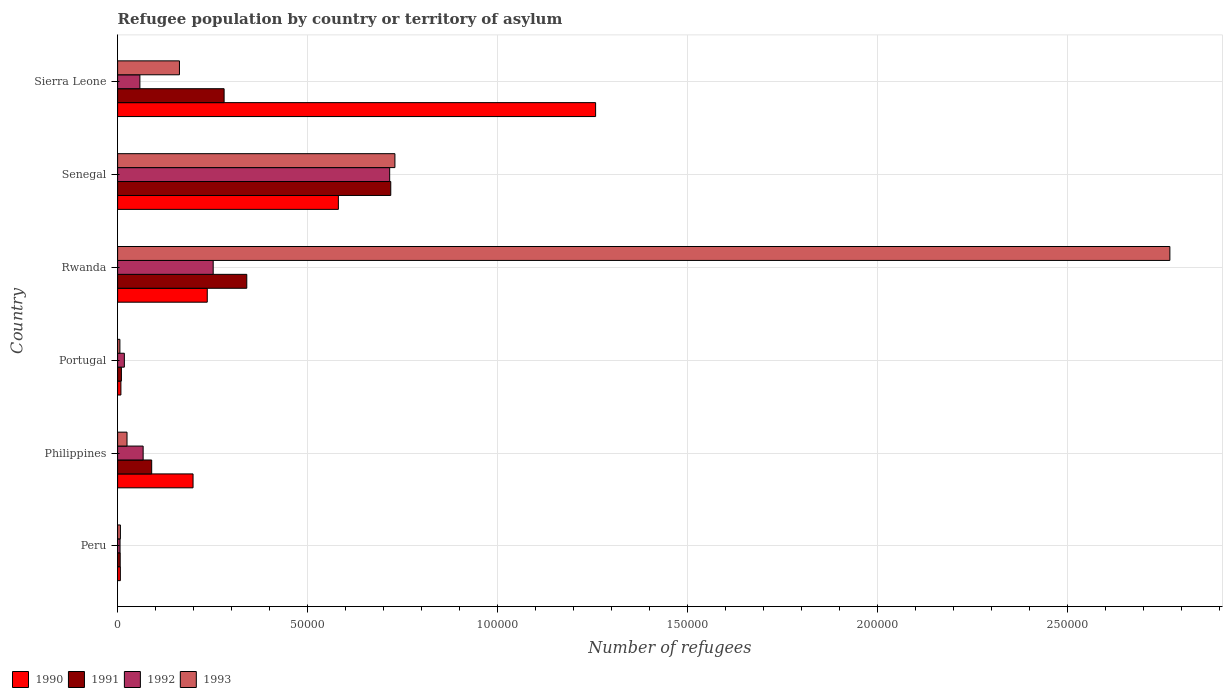Are the number of bars per tick equal to the number of legend labels?
Offer a terse response. Yes. Are the number of bars on each tick of the Y-axis equal?
Your answer should be compact. Yes. How many bars are there on the 4th tick from the bottom?
Ensure brevity in your answer.  4. What is the label of the 1st group of bars from the top?
Make the answer very short. Sierra Leone. In how many cases, is the number of bars for a given country not equal to the number of legend labels?
Your response must be concise. 0. What is the number of refugees in 1991 in Rwanda?
Your response must be concise. 3.40e+04. Across all countries, what is the maximum number of refugees in 1990?
Your answer should be compact. 1.26e+05. Across all countries, what is the minimum number of refugees in 1990?
Offer a terse response. 724. In which country was the number of refugees in 1993 maximum?
Provide a short and direct response. Rwanda. In which country was the number of refugees in 1991 minimum?
Provide a succinct answer. Peru. What is the total number of refugees in 1990 in the graph?
Give a very brief answer. 2.29e+05. What is the difference between the number of refugees in 1991 in Philippines and that in Sierra Leone?
Your answer should be very brief. -1.91e+04. What is the difference between the number of refugees in 1992 in Portugal and the number of refugees in 1990 in Senegal?
Ensure brevity in your answer.  -5.63e+04. What is the average number of refugees in 1993 per country?
Your response must be concise. 6.17e+04. What is the difference between the number of refugees in 1990 and number of refugees in 1993 in Sierra Leone?
Keep it short and to the point. 1.10e+05. What is the ratio of the number of refugees in 1993 in Philippines to that in Senegal?
Ensure brevity in your answer.  0.03. What is the difference between the highest and the second highest number of refugees in 1993?
Keep it short and to the point. 2.04e+05. What is the difference between the highest and the lowest number of refugees in 1992?
Provide a succinct answer. 7.10e+04. In how many countries, is the number of refugees in 1991 greater than the average number of refugees in 1991 taken over all countries?
Ensure brevity in your answer.  3. Is the sum of the number of refugees in 1993 in Portugal and Rwanda greater than the maximum number of refugees in 1991 across all countries?
Ensure brevity in your answer.  Yes. Is it the case that in every country, the sum of the number of refugees in 1992 and number of refugees in 1991 is greater than the sum of number of refugees in 1990 and number of refugees in 1993?
Provide a succinct answer. No. What does the 4th bar from the top in Peru represents?
Your answer should be very brief. 1990. How many bars are there?
Your response must be concise. 24. Are the values on the major ticks of X-axis written in scientific E-notation?
Your answer should be compact. No. Does the graph contain any zero values?
Make the answer very short. No. Where does the legend appear in the graph?
Make the answer very short. Bottom left. How many legend labels are there?
Provide a succinct answer. 4. How are the legend labels stacked?
Your answer should be very brief. Horizontal. What is the title of the graph?
Provide a short and direct response. Refugee population by country or territory of asylum. What is the label or title of the X-axis?
Provide a short and direct response. Number of refugees. What is the Number of refugees of 1990 in Peru?
Your answer should be very brief. 724. What is the Number of refugees in 1991 in Peru?
Give a very brief answer. 683. What is the Number of refugees in 1992 in Peru?
Give a very brief answer. 640. What is the Number of refugees of 1993 in Peru?
Offer a terse response. 738. What is the Number of refugees of 1990 in Philippines?
Make the answer very short. 1.99e+04. What is the Number of refugees of 1991 in Philippines?
Your response must be concise. 8972. What is the Number of refugees of 1992 in Philippines?
Provide a succinct answer. 6722. What is the Number of refugees of 1993 in Philippines?
Offer a terse response. 2477. What is the Number of refugees of 1990 in Portugal?
Ensure brevity in your answer.  867. What is the Number of refugees in 1991 in Portugal?
Ensure brevity in your answer.  998. What is the Number of refugees of 1992 in Portugal?
Keep it short and to the point. 1778. What is the Number of refugees in 1993 in Portugal?
Ensure brevity in your answer.  600. What is the Number of refugees of 1990 in Rwanda?
Keep it short and to the point. 2.36e+04. What is the Number of refugees of 1991 in Rwanda?
Provide a short and direct response. 3.40e+04. What is the Number of refugees of 1992 in Rwanda?
Your answer should be very brief. 2.52e+04. What is the Number of refugees in 1993 in Rwanda?
Your answer should be compact. 2.77e+05. What is the Number of refugees in 1990 in Senegal?
Make the answer very short. 5.81e+04. What is the Number of refugees in 1991 in Senegal?
Your answer should be compact. 7.19e+04. What is the Number of refugees of 1992 in Senegal?
Offer a very short reply. 7.16e+04. What is the Number of refugees in 1993 in Senegal?
Keep it short and to the point. 7.30e+04. What is the Number of refugees of 1990 in Sierra Leone?
Offer a very short reply. 1.26e+05. What is the Number of refugees in 1991 in Sierra Leone?
Provide a succinct answer. 2.80e+04. What is the Number of refugees of 1992 in Sierra Leone?
Your answer should be compact. 5866. What is the Number of refugees in 1993 in Sierra Leone?
Provide a succinct answer. 1.63e+04. Across all countries, what is the maximum Number of refugees in 1990?
Ensure brevity in your answer.  1.26e+05. Across all countries, what is the maximum Number of refugees in 1991?
Offer a very short reply. 7.19e+04. Across all countries, what is the maximum Number of refugees in 1992?
Give a very brief answer. 7.16e+04. Across all countries, what is the maximum Number of refugees of 1993?
Ensure brevity in your answer.  2.77e+05. Across all countries, what is the minimum Number of refugees of 1990?
Provide a succinct answer. 724. Across all countries, what is the minimum Number of refugees of 1991?
Offer a very short reply. 683. Across all countries, what is the minimum Number of refugees in 1992?
Offer a very short reply. 640. Across all countries, what is the minimum Number of refugees of 1993?
Ensure brevity in your answer.  600. What is the total Number of refugees in 1990 in the graph?
Keep it short and to the point. 2.29e+05. What is the total Number of refugees of 1991 in the graph?
Keep it short and to the point. 1.45e+05. What is the total Number of refugees of 1992 in the graph?
Offer a terse response. 1.12e+05. What is the total Number of refugees in 1993 in the graph?
Your response must be concise. 3.70e+05. What is the difference between the Number of refugees in 1990 in Peru and that in Philippines?
Your answer should be very brief. -1.91e+04. What is the difference between the Number of refugees in 1991 in Peru and that in Philippines?
Give a very brief answer. -8289. What is the difference between the Number of refugees of 1992 in Peru and that in Philippines?
Provide a succinct answer. -6082. What is the difference between the Number of refugees in 1993 in Peru and that in Philippines?
Offer a terse response. -1739. What is the difference between the Number of refugees in 1990 in Peru and that in Portugal?
Your answer should be compact. -143. What is the difference between the Number of refugees of 1991 in Peru and that in Portugal?
Provide a short and direct response. -315. What is the difference between the Number of refugees in 1992 in Peru and that in Portugal?
Ensure brevity in your answer.  -1138. What is the difference between the Number of refugees of 1993 in Peru and that in Portugal?
Your answer should be very brief. 138. What is the difference between the Number of refugees in 1990 in Peru and that in Rwanda?
Ensure brevity in your answer.  -2.29e+04. What is the difference between the Number of refugees of 1991 in Peru and that in Rwanda?
Give a very brief answer. -3.33e+04. What is the difference between the Number of refugees in 1992 in Peru and that in Rwanda?
Offer a terse response. -2.45e+04. What is the difference between the Number of refugees in 1993 in Peru and that in Rwanda?
Keep it short and to the point. -2.76e+05. What is the difference between the Number of refugees in 1990 in Peru and that in Senegal?
Give a very brief answer. -5.74e+04. What is the difference between the Number of refugees in 1991 in Peru and that in Senegal?
Provide a succinct answer. -7.12e+04. What is the difference between the Number of refugees in 1992 in Peru and that in Senegal?
Your answer should be compact. -7.10e+04. What is the difference between the Number of refugees in 1993 in Peru and that in Senegal?
Give a very brief answer. -7.23e+04. What is the difference between the Number of refugees in 1990 in Peru and that in Sierra Leone?
Give a very brief answer. -1.25e+05. What is the difference between the Number of refugees in 1991 in Peru and that in Sierra Leone?
Give a very brief answer. -2.74e+04. What is the difference between the Number of refugees in 1992 in Peru and that in Sierra Leone?
Provide a short and direct response. -5226. What is the difference between the Number of refugees in 1993 in Peru and that in Sierra Leone?
Give a very brief answer. -1.55e+04. What is the difference between the Number of refugees in 1990 in Philippines and that in Portugal?
Keep it short and to the point. 1.90e+04. What is the difference between the Number of refugees of 1991 in Philippines and that in Portugal?
Provide a short and direct response. 7974. What is the difference between the Number of refugees of 1992 in Philippines and that in Portugal?
Your answer should be compact. 4944. What is the difference between the Number of refugees in 1993 in Philippines and that in Portugal?
Your answer should be compact. 1877. What is the difference between the Number of refugees of 1990 in Philippines and that in Rwanda?
Provide a succinct answer. -3741. What is the difference between the Number of refugees of 1991 in Philippines and that in Rwanda?
Give a very brief answer. -2.50e+04. What is the difference between the Number of refugees in 1992 in Philippines and that in Rwanda?
Provide a succinct answer. -1.84e+04. What is the difference between the Number of refugees of 1993 in Philippines and that in Rwanda?
Give a very brief answer. -2.75e+05. What is the difference between the Number of refugees in 1990 in Philippines and that in Senegal?
Your response must be concise. -3.83e+04. What is the difference between the Number of refugees in 1991 in Philippines and that in Senegal?
Your response must be concise. -6.29e+04. What is the difference between the Number of refugees in 1992 in Philippines and that in Senegal?
Make the answer very short. -6.49e+04. What is the difference between the Number of refugees of 1993 in Philippines and that in Senegal?
Offer a very short reply. -7.05e+04. What is the difference between the Number of refugees in 1990 in Philippines and that in Sierra Leone?
Make the answer very short. -1.06e+05. What is the difference between the Number of refugees of 1991 in Philippines and that in Sierra Leone?
Offer a very short reply. -1.91e+04. What is the difference between the Number of refugees of 1992 in Philippines and that in Sierra Leone?
Keep it short and to the point. 856. What is the difference between the Number of refugees in 1993 in Philippines and that in Sierra Leone?
Make the answer very short. -1.38e+04. What is the difference between the Number of refugees of 1990 in Portugal and that in Rwanda?
Provide a short and direct response. -2.27e+04. What is the difference between the Number of refugees of 1991 in Portugal and that in Rwanda?
Make the answer very short. -3.30e+04. What is the difference between the Number of refugees in 1992 in Portugal and that in Rwanda?
Give a very brief answer. -2.34e+04. What is the difference between the Number of refugees in 1993 in Portugal and that in Rwanda?
Give a very brief answer. -2.76e+05. What is the difference between the Number of refugees of 1990 in Portugal and that in Senegal?
Make the answer very short. -5.72e+04. What is the difference between the Number of refugees in 1991 in Portugal and that in Senegal?
Provide a succinct answer. -7.09e+04. What is the difference between the Number of refugees in 1992 in Portugal and that in Senegal?
Make the answer very short. -6.98e+04. What is the difference between the Number of refugees in 1993 in Portugal and that in Senegal?
Your response must be concise. -7.24e+04. What is the difference between the Number of refugees of 1990 in Portugal and that in Sierra Leone?
Provide a short and direct response. -1.25e+05. What is the difference between the Number of refugees of 1991 in Portugal and that in Sierra Leone?
Provide a short and direct response. -2.70e+04. What is the difference between the Number of refugees of 1992 in Portugal and that in Sierra Leone?
Your answer should be compact. -4088. What is the difference between the Number of refugees of 1993 in Portugal and that in Sierra Leone?
Make the answer very short. -1.57e+04. What is the difference between the Number of refugees of 1990 in Rwanda and that in Senegal?
Your answer should be very brief. -3.45e+04. What is the difference between the Number of refugees of 1991 in Rwanda and that in Senegal?
Provide a succinct answer. -3.79e+04. What is the difference between the Number of refugees of 1992 in Rwanda and that in Senegal?
Offer a terse response. -4.65e+04. What is the difference between the Number of refugees of 1993 in Rwanda and that in Senegal?
Offer a very short reply. 2.04e+05. What is the difference between the Number of refugees of 1990 in Rwanda and that in Sierra Leone?
Your answer should be compact. -1.02e+05. What is the difference between the Number of refugees in 1991 in Rwanda and that in Sierra Leone?
Your response must be concise. 5968. What is the difference between the Number of refugees of 1992 in Rwanda and that in Sierra Leone?
Provide a succinct answer. 1.93e+04. What is the difference between the Number of refugees in 1993 in Rwanda and that in Sierra Leone?
Your response must be concise. 2.61e+05. What is the difference between the Number of refugees in 1990 in Senegal and that in Sierra Leone?
Your answer should be compact. -6.77e+04. What is the difference between the Number of refugees in 1991 in Senegal and that in Sierra Leone?
Your answer should be very brief. 4.39e+04. What is the difference between the Number of refugees in 1992 in Senegal and that in Sierra Leone?
Give a very brief answer. 6.58e+04. What is the difference between the Number of refugees of 1993 in Senegal and that in Sierra Leone?
Give a very brief answer. 5.67e+04. What is the difference between the Number of refugees of 1990 in Peru and the Number of refugees of 1991 in Philippines?
Offer a very short reply. -8248. What is the difference between the Number of refugees in 1990 in Peru and the Number of refugees in 1992 in Philippines?
Your response must be concise. -5998. What is the difference between the Number of refugees of 1990 in Peru and the Number of refugees of 1993 in Philippines?
Provide a succinct answer. -1753. What is the difference between the Number of refugees of 1991 in Peru and the Number of refugees of 1992 in Philippines?
Provide a short and direct response. -6039. What is the difference between the Number of refugees of 1991 in Peru and the Number of refugees of 1993 in Philippines?
Make the answer very short. -1794. What is the difference between the Number of refugees of 1992 in Peru and the Number of refugees of 1993 in Philippines?
Your response must be concise. -1837. What is the difference between the Number of refugees in 1990 in Peru and the Number of refugees in 1991 in Portugal?
Offer a terse response. -274. What is the difference between the Number of refugees in 1990 in Peru and the Number of refugees in 1992 in Portugal?
Provide a succinct answer. -1054. What is the difference between the Number of refugees of 1990 in Peru and the Number of refugees of 1993 in Portugal?
Your answer should be compact. 124. What is the difference between the Number of refugees of 1991 in Peru and the Number of refugees of 1992 in Portugal?
Make the answer very short. -1095. What is the difference between the Number of refugees of 1991 in Peru and the Number of refugees of 1993 in Portugal?
Your answer should be compact. 83. What is the difference between the Number of refugees in 1992 in Peru and the Number of refugees in 1993 in Portugal?
Your response must be concise. 40. What is the difference between the Number of refugees of 1990 in Peru and the Number of refugees of 1991 in Rwanda?
Provide a succinct answer. -3.33e+04. What is the difference between the Number of refugees of 1990 in Peru and the Number of refugees of 1992 in Rwanda?
Give a very brief answer. -2.44e+04. What is the difference between the Number of refugees of 1990 in Peru and the Number of refugees of 1993 in Rwanda?
Your answer should be compact. -2.76e+05. What is the difference between the Number of refugees in 1991 in Peru and the Number of refugees in 1992 in Rwanda?
Your answer should be compact. -2.45e+04. What is the difference between the Number of refugees in 1991 in Peru and the Number of refugees in 1993 in Rwanda?
Your response must be concise. -2.76e+05. What is the difference between the Number of refugees of 1992 in Peru and the Number of refugees of 1993 in Rwanda?
Keep it short and to the point. -2.76e+05. What is the difference between the Number of refugees in 1990 in Peru and the Number of refugees in 1991 in Senegal?
Ensure brevity in your answer.  -7.12e+04. What is the difference between the Number of refugees of 1990 in Peru and the Number of refugees of 1992 in Senegal?
Keep it short and to the point. -7.09e+04. What is the difference between the Number of refugees in 1990 in Peru and the Number of refugees in 1993 in Senegal?
Provide a short and direct response. -7.23e+04. What is the difference between the Number of refugees in 1991 in Peru and the Number of refugees in 1992 in Senegal?
Your response must be concise. -7.09e+04. What is the difference between the Number of refugees of 1991 in Peru and the Number of refugees of 1993 in Senegal?
Make the answer very short. -7.23e+04. What is the difference between the Number of refugees in 1992 in Peru and the Number of refugees in 1993 in Senegal?
Ensure brevity in your answer.  -7.24e+04. What is the difference between the Number of refugees of 1990 in Peru and the Number of refugees of 1991 in Sierra Leone?
Offer a very short reply. -2.73e+04. What is the difference between the Number of refugees of 1990 in Peru and the Number of refugees of 1992 in Sierra Leone?
Make the answer very short. -5142. What is the difference between the Number of refugees of 1990 in Peru and the Number of refugees of 1993 in Sierra Leone?
Ensure brevity in your answer.  -1.56e+04. What is the difference between the Number of refugees of 1991 in Peru and the Number of refugees of 1992 in Sierra Leone?
Keep it short and to the point. -5183. What is the difference between the Number of refugees of 1991 in Peru and the Number of refugees of 1993 in Sierra Leone?
Your answer should be compact. -1.56e+04. What is the difference between the Number of refugees of 1992 in Peru and the Number of refugees of 1993 in Sierra Leone?
Your answer should be very brief. -1.56e+04. What is the difference between the Number of refugees of 1990 in Philippines and the Number of refugees of 1991 in Portugal?
Give a very brief answer. 1.89e+04. What is the difference between the Number of refugees in 1990 in Philippines and the Number of refugees in 1992 in Portugal?
Give a very brief answer. 1.81e+04. What is the difference between the Number of refugees of 1990 in Philippines and the Number of refugees of 1993 in Portugal?
Your answer should be compact. 1.93e+04. What is the difference between the Number of refugees of 1991 in Philippines and the Number of refugees of 1992 in Portugal?
Your answer should be very brief. 7194. What is the difference between the Number of refugees in 1991 in Philippines and the Number of refugees in 1993 in Portugal?
Ensure brevity in your answer.  8372. What is the difference between the Number of refugees in 1992 in Philippines and the Number of refugees in 1993 in Portugal?
Offer a very short reply. 6122. What is the difference between the Number of refugees of 1990 in Philippines and the Number of refugees of 1991 in Rwanda?
Ensure brevity in your answer.  -1.41e+04. What is the difference between the Number of refugees in 1990 in Philippines and the Number of refugees in 1992 in Rwanda?
Your answer should be very brief. -5302. What is the difference between the Number of refugees in 1990 in Philippines and the Number of refugees in 1993 in Rwanda?
Offer a very short reply. -2.57e+05. What is the difference between the Number of refugees of 1991 in Philippines and the Number of refugees of 1992 in Rwanda?
Offer a terse response. -1.62e+04. What is the difference between the Number of refugees in 1991 in Philippines and the Number of refugees in 1993 in Rwanda?
Offer a very short reply. -2.68e+05. What is the difference between the Number of refugees in 1992 in Philippines and the Number of refugees in 1993 in Rwanda?
Your answer should be compact. -2.70e+05. What is the difference between the Number of refugees in 1990 in Philippines and the Number of refugees in 1991 in Senegal?
Keep it short and to the point. -5.20e+04. What is the difference between the Number of refugees in 1990 in Philippines and the Number of refugees in 1992 in Senegal?
Keep it short and to the point. -5.18e+04. What is the difference between the Number of refugees of 1990 in Philippines and the Number of refugees of 1993 in Senegal?
Provide a short and direct response. -5.31e+04. What is the difference between the Number of refugees in 1991 in Philippines and the Number of refugees in 1992 in Senegal?
Keep it short and to the point. -6.26e+04. What is the difference between the Number of refugees in 1991 in Philippines and the Number of refugees in 1993 in Senegal?
Offer a very short reply. -6.40e+04. What is the difference between the Number of refugees in 1992 in Philippines and the Number of refugees in 1993 in Senegal?
Provide a succinct answer. -6.63e+04. What is the difference between the Number of refugees of 1990 in Philippines and the Number of refugees of 1991 in Sierra Leone?
Your answer should be compact. -8176. What is the difference between the Number of refugees of 1990 in Philippines and the Number of refugees of 1992 in Sierra Leone?
Give a very brief answer. 1.40e+04. What is the difference between the Number of refugees in 1990 in Philippines and the Number of refugees in 1993 in Sierra Leone?
Your answer should be compact. 3581. What is the difference between the Number of refugees in 1991 in Philippines and the Number of refugees in 1992 in Sierra Leone?
Your answer should be compact. 3106. What is the difference between the Number of refugees of 1991 in Philippines and the Number of refugees of 1993 in Sierra Leone?
Your response must be concise. -7307. What is the difference between the Number of refugees in 1992 in Philippines and the Number of refugees in 1993 in Sierra Leone?
Offer a terse response. -9557. What is the difference between the Number of refugees in 1990 in Portugal and the Number of refugees in 1991 in Rwanda?
Make the answer very short. -3.31e+04. What is the difference between the Number of refugees of 1990 in Portugal and the Number of refugees of 1992 in Rwanda?
Make the answer very short. -2.43e+04. What is the difference between the Number of refugees of 1990 in Portugal and the Number of refugees of 1993 in Rwanda?
Ensure brevity in your answer.  -2.76e+05. What is the difference between the Number of refugees in 1991 in Portugal and the Number of refugees in 1992 in Rwanda?
Provide a short and direct response. -2.42e+04. What is the difference between the Number of refugees of 1991 in Portugal and the Number of refugees of 1993 in Rwanda?
Your answer should be compact. -2.76e+05. What is the difference between the Number of refugees in 1992 in Portugal and the Number of refugees in 1993 in Rwanda?
Ensure brevity in your answer.  -2.75e+05. What is the difference between the Number of refugees of 1990 in Portugal and the Number of refugees of 1991 in Senegal?
Your response must be concise. -7.10e+04. What is the difference between the Number of refugees of 1990 in Portugal and the Number of refugees of 1992 in Senegal?
Your response must be concise. -7.08e+04. What is the difference between the Number of refugees of 1990 in Portugal and the Number of refugees of 1993 in Senegal?
Your answer should be compact. -7.21e+04. What is the difference between the Number of refugees of 1991 in Portugal and the Number of refugees of 1992 in Senegal?
Your response must be concise. -7.06e+04. What is the difference between the Number of refugees in 1991 in Portugal and the Number of refugees in 1993 in Senegal?
Offer a terse response. -7.20e+04. What is the difference between the Number of refugees in 1992 in Portugal and the Number of refugees in 1993 in Senegal?
Make the answer very short. -7.12e+04. What is the difference between the Number of refugees in 1990 in Portugal and the Number of refugees in 1991 in Sierra Leone?
Your answer should be compact. -2.72e+04. What is the difference between the Number of refugees of 1990 in Portugal and the Number of refugees of 1992 in Sierra Leone?
Offer a very short reply. -4999. What is the difference between the Number of refugees in 1990 in Portugal and the Number of refugees in 1993 in Sierra Leone?
Make the answer very short. -1.54e+04. What is the difference between the Number of refugees in 1991 in Portugal and the Number of refugees in 1992 in Sierra Leone?
Your response must be concise. -4868. What is the difference between the Number of refugees of 1991 in Portugal and the Number of refugees of 1993 in Sierra Leone?
Provide a short and direct response. -1.53e+04. What is the difference between the Number of refugees of 1992 in Portugal and the Number of refugees of 1993 in Sierra Leone?
Keep it short and to the point. -1.45e+04. What is the difference between the Number of refugees in 1990 in Rwanda and the Number of refugees in 1991 in Senegal?
Your answer should be compact. -4.83e+04. What is the difference between the Number of refugees in 1990 in Rwanda and the Number of refugees in 1992 in Senegal?
Give a very brief answer. -4.80e+04. What is the difference between the Number of refugees of 1990 in Rwanda and the Number of refugees of 1993 in Senegal?
Offer a very short reply. -4.94e+04. What is the difference between the Number of refugees in 1991 in Rwanda and the Number of refugees in 1992 in Senegal?
Offer a very short reply. -3.76e+04. What is the difference between the Number of refugees of 1991 in Rwanda and the Number of refugees of 1993 in Senegal?
Offer a terse response. -3.90e+04. What is the difference between the Number of refugees in 1992 in Rwanda and the Number of refugees in 1993 in Senegal?
Give a very brief answer. -4.78e+04. What is the difference between the Number of refugees in 1990 in Rwanda and the Number of refugees in 1991 in Sierra Leone?
Offer a very short reply. -4435. What is the difference between the Number of refugees in 1990 in Rwanda and the Number of refugees in 1992 in Sierra Leone?
Make the answer very short. 1.77e+04. What is the difference between the Number of refugees in 1990 in Rwanda and the Number of refugees in 1993 in Sierra Leone?
Provide a succinct answer. 7322. What is the difference between the Number of refugees in 1991 in Rwanda and the Number of refugees in 1992 in Sierra Leone?
Offer a very short reply. 2.81e+04. What is the difference between the Number of refugees of 1991 in Rwanda and the Number of refugees of 1993 in Sierra Leone?
Give a very brief answer. 1.77e+04. What is the difference between the Number of refugees of 1992 in Rwanda and the Number of refugees of 1993 in Sierra Leone?
Provide a short and direct response. 8883. What is the difference between the Number of refugees of 1990 in Senegal and the Number of refugees of 1991 in Sierra Leone?
Give a very brief answer. 3.01e+04. What is the difference between the Number of refugees in 1990 in Senegal and the Number of refugees in 1992 in Sierra Leone?
Provide a succinct answer. 5.22e+04. What is the difference between the Number of refugees in 1990 in Senegal and the Number of refugees in 1993 in Sierra Leone?
Ensure brevity in your answer.  4.18e+04. What is the difference between the Number of refugees of 1991 in Senegal and the Number of refugees of 1992 in Sierra Leone?
Give a very brief answer. 6.60e+04. What is the difference between the Number of refugees of 1991 in Senegal and the Number of refugees of 1993 in Sierra Leone?
Your answer should be very brief. 5.56e+04. What is the difference between the Number of refugees in 1992 in Senegal and the Number of refugees in 1993 in Sierra Leone?
Offer a terse response. 5.53e+04. What is the average Number of refugees in 1990 per country?
Your answer should be very brief. 3.82e+04. What is the average Number of refugees in 1991 per country?
Your answer should be compact. 2.41e+04. What is the average Number of refugees in 1992 per country?
Offer a terse response. 1.86e+04. What is the average Number of refugees in 1993 per country?
Your response must be concise. 6.17e+04. What is the difference between the Number of refugees of 1990 and Number of refugees of 1991 in Peru?
Offer a very short reply. 41. What is the difference between the Number of refugees of 1990 and Number of refugees of 1992 in Peru?
Your answer should be compact. 84. What is the difference between the Number of refugees of 1991 and Number of refugees of 1993 in Peru?
Ensure brevity in your answer.  -55. What is the difference between the Number of refugees in 1992 and Number of refugees in 1993 in Peru?
Ensure brevity in your answer.  -98. What is the difference between the Number of refugees of 1990 and Number of refugees of 1991 in Philippines?
Make the answer very short. 1.09e+04. What is the difference between the Number of refugees of 1990 and Number of refugees of 1992 in Philippines?
Provide a short and direct response. 1.31e+04. What is the difference between the Number of refugees of 1990 and Number of refugees of 1993 in Philippines?
Provide a short and direct response. 1.74e+04. What is the difference between the Number of refugees in 1991 and Number of refugees in 1992 in Philippines?
Ensure brevity in your answer.  2250. What is the difference between the Number of refugees in 1991 and Number of refugees in 1993 in Philippines?
Keep it short and to the point. 6495. What is the difference between the Number of refugees in 1992 and Number of refugees in 1993 in Philippines?
Offer a very short reply. 4245. What is the difference between the Number of refugees of 1990 and Number of refugees of 1991 in Portugal?
Provide a short and direct response. -131. What is the difference between the Number of refugees in 1990 and Number of refugees in 1992 in Portugal?
Make the answer very short. -911. What is the difference between the Number of refugees in 1990 and Number of refugees in 1993 in Portugal?
Your response must be concise. 267. What is the difference between the Number of refugees in 1991 and Number of refugees in 1992 in Portugal?
Provide a short and direct response. -780. What is the difference between the Number of refugees of 1991 and Number of refugees of 1993 in Portugal?
Provide a succinct answer. 398. What is the difference between the Number of refugees in 1992 and Number of refugees in 1993 in Portugal?
Your answer should be very brief. 1178. What is the difference between the Number of refugees in 1990 and Number of refugees in 1991 in Rwanda?
Provide a short and direct response. -1.04e+04. What is the difference between the Number of refugees of 1990 and Number of refugees of 1992 in Rwanda?
Provide a succinct answer. -1561. What is the difference between the Number of refugees of 1990 and Number of refugees of 1993 in Rwanda?
Offer a terse response. -2.53e+05. What is the difference between the Number of refugees in 1991 and Number of refugees in 1992 in Rwanda?
Your answer should be compact. 8842. What is the difference between the Number of refugees of 1991 and Number of refugees of 1993 in Rwanda?
Make the answer very short. -2.43e+05. What is the difference between the Number of refugees in 1992 and Number of refugees in 1993 in Rwanda?
Make the answer very short. -2.52e+05. What is the difference between the Number of refugees in 1990 and Number of refugees in 1991 in Senegal?
Your response must be concise. -1.38e+04. What is the difference between the Number of refugees of 1990 and Number of refugees of 1992 in Senegal?
Your answer should be very brief. -1.35e+04. What is the difference between the Number of refugees in 1990 and Number of refugees in 1993 in Senegal?
Offer a terse response. -1.49e+04. What is the difference between the Number of refugees in 1991 and Number of refugees in 1992 in Senegal?
Offer a very short reply. 288. What is the difference between the Number of refugees of 1991 and Number of refugees of 1993 in Senegal?
Give a very brief answer. -1094. What is the difference between the Number of refugees in 1992 and Number of refugees in 1993 in Senegal?
Provide a succinct answer. -1382. What is the difference between the Number of refugees of 1990 and Number of refugees of 1991 in Sierra Leone?
Provide a short and direct response. 9.78e+04. What is the difference between the Number of refugees in 1990 and Number of refugees in 1992 in Sierra Leone?
Give a very brief answer. 1.20e+05. What is the difference between the Number of refugees in 1990 and Number of refugees in 1993 in Sierra Leone?
Your response must be concise. 1.10e+05. What is the difference between the Number of refugees in 1991 and Number of refugees in 1992 in Sierra Leone?
Your answer should be compact. 2.22e+04. What is the difference between the Number of refugees of 1991 and Number of refugees of 1993 in Sierra Leone?
Your answer should be compact. 1.18e+04. What is the difference between the Number of refugees in 1992 and Number of refugees in 1993 in Sierra Leone?
Make the answer very short. -1.04e+04. What is the ratio of the Number of refugees of 1990 in Peru to that in Philippines?
Ensure brevity in your answer.  0.04. What is the ratio of the Number of refugees of 1991 in Peru to that in Philippines?
Offer a terse response. 0.08. What is the ratio of the Number of refugees in 1992 in Peru to that in Philippines?
Provide a succinct answer. 0.1. What is the ratio of the Number of refugees in 1993 in Peru to that in Philippines?
Your answer should be very brief. 0.3. What is the ratio of the Number of refugees of 1990 in Peru to that in Portugal?
Make the answer very short. 0.84. What is the ratio of the Number of refugees of 1991 in Peru to that in Portugal?
Give a very brief answer. 0.68. What is the ratio of the Number of refugees of 1992 in Peru to that in Portugal?
Provide a succinct answer. 0.36. What is the ratio of the Number of refugees in 1993 in Peru to that in Portugal?
Your response must be concise. 1.23. What is the ratio of the Number of refugees in 1990 in Peru to that in Rwanda?
Your response must be concise. 0.03. What is the ratio of the Number of refugees of 1991 in Peru to that in Rwanda?
Your answer should be very brief. 0.02. What is the ratio of the Number of refugees in 1992 in Peru to that in Rwanda?
Provide a short and direct response. 0.03. What is the ratio of the Number of refugees of 1993 in Peru to that in Rwanda?
Offer a terse response. 0. What is the ratio of the Number of refugees of 1990 in Peru to that in Senegal?
Offer a terse response. 0.01. What is the ratio of the Number of refugees in 1991 in Peru to that in Senegal?
Make the answer very short. 0.01. What is the ratio of the Number of refugees of 1992 in Peru to that in Senegal?
Provide a short and direct response. 0.01. What is the ratio of the Number of refugees in 1993 in Peru to that in Senegal?
Keep it short and to the point. 0.01. What is the ratio of the Number of refugees in 1990 in Peru to that in Sierra Leone?
Offer a terse response. 0.01. What is the ratio of the Number of refugees of 1991 in Peru to that in Sierra Leone?
Your answer should be compact. 0.02. What is the ratio of the Number of refugees of 1992 in Peru to that in Sierra Leone?
Provide a succinct answer. 0.11. What is the ratio of the Number of refugees in 1993 in Peru to that in Sierra Leone?
Provide a succinct answer. 0.05. What is the ratio of the Number of refugees in 1990 in Philippines to that in Portugal?
Provide a short and direct response. 22.91. What is the ratio of the Number of refugees in 1991 in Philippines to that in Portugal?
Offer a very short reply. 8.99. What is the ratio of the Number of refugees in 1992 in Philippines to that in Portugal?
Keep it short and to the point. 3.78. What is the ratio of the Number of refugees in 1993 in Philippines to that in Portugal?
Your answer should be compact. 4.13. What is the ratio of the Number of refugees in 1990 in Philippines to that in Rwanda?
Make the answer very short. 0.84. What is the ratio of the Number of refugees of 1991 in Philippines to that in Rwanda?
Make the answer very short. 0.26. What is the ratio of the Number of refugees of 1992 in Philippines to that in Rwanda?
Provide a short and direct response. 0.27. What is the ratio of the Number of refugees in 1993 in Philippines to that in Rwanda?
Provide a short and direct response. 0.01. What is the ratio of the Number of refugees of 1990 in Philippines to that in Senegal?
Give a very brief answer. 0.34. What is the ratio of the Number of refugees of 1991 in Philippines to that in Senegal?
Keep it short and to the point. 0.12. What is the ratio of the Number of refugees of 1992 in Philippines to that in Senegal?
Make the answer very short. 0.09. What is the ratio of the Number of refugees in 1993 in Philippines to that in Senegal?
Provide a succinct answer. 0.03. What is the ratio of the Number of refugees of 1990 in Philippines to that in Sierra Leone?
Your response must be concise. 0.16. What is the ratio of the Number of refugees of 1991 in Philippines to that in Sierra Leone?
Provide a succinct answer. 0.32. What is the ratio of the Number of refugees of 1992 in Philippines to that in Sierra Leone?
Offer a terse response. 1.15. What is the ratio of the Number of refugees in 1993 in Philippines to that in Sierra Leone?
Your response must be concise. 0.15. What is the ratio of the Number of refugees of 1990 in Portugal to that in Rwanda?
Provide a succinct answer. 0.04. What is the ratio of the Number of refugees in 1991 in Portugal to that in Rwanda?
Your response must be concise. 0.03. What is the ratio of the Number of refugees of 1992 in Portugal to that in Rwanda?
Your response must be concise. 0.07. What is the ratio of the Number of refugees of 1993 in Portugal to that in Rwanda?
Offer a terse response. 0. What is the ratio of the Number of refugees of 1990 in Portugal to that in Senegal?
Offer a very short reply. 0.01. What is the ratio of the Number of refugees in 1991 in Portugal to that in Senegal?
Give a very brief answer. 0.01. What is the ratio of the Number of refugees in 1992 in Portugal to that in Senegal?
Ensure brevity in your answer.  0.02. What is the ratio of the Number of refugees in 1993 in Portugal to that in Senegal?
Your answer should be very brief. 0.01. What is the ratio of the Number of refugees in 1990 in Portugal to that in Sierra Leone?
Your answer should be compact. 0.01. What is the ratio of the Number of refugees of 1991 in Portugal to that in Sierra Leone?
Offer a terse response. 0.04. What is the ratio of the Number of refugees of 1992 in Portugal to that in Sierra Leone?
Your response must be concise. 0.3. What is the ratio of the Number of refugees of 1993 in Portugal to that in Sierra Leone?
Provide a short and direct response. 0.04. What is the ratio of the Number of refugees of 1990 in Rwanda to that in Senegal?
Give a very brief answer. 0.41. What is the ratio of the Number of refugees of 1991 in Rwanda to that in Senegal?
Offer a very short reply. 0.47. What is the ratio of the Number of refugees of 1992 in Rwanda to that in Senegal?
Keep it short and to the point. 0.35. What is the ratio of the Number of refugees in 1993 in Rwanda to that in Senegal?
Your answer should be compact. 3.79. What is the ratio of the Number of refugees of 1990 in Rwanda to that in Sierra Leone?
Your response must be concise. 0.19. What is the ratio of the Number of refugees in 1991 in Rwanda to that in Sierra Leone?
Offer a terse response. 1.21. What is the ratio of the Number of refugees of 1992 in Rwanda to that in Sierra Leone?
Your answer should be compact. 4.29. What is the ratio of the Number of refugees in 1993 in Rwanda to that in Sierra Leone?
Give a very brief answer. 17.02. What is the ratio of the Number of refugees in 1990 in Senegal to that in Sierra Leone?
Your answer should be compact. 0.46. What is the ratio of the Number of refugees in 1991 in Senegal to that in Sierra Leone?
Provide a succinct answer. 2.56. What is the ratio of the Number of refugees in 1992 in Senegal to that in Sierra Leone?
Your response must be concise. 12.21. What is the ratio of the Number of refugees of 1993 in Senegal to that in Sierra Leone?
Provide a short and direct response. 4.48. What is the difference between the highest and the second highest Number of refugees of 1990?
Ensure brevity in your answer.  6.77e+04. What is the difference between the highest and the second highest Number of refugees of 1991?
Ensure brevity in your answer.  3.79e+04. What is the difference between the highest and the second highest Number of refugees in 1992?
Provide a succinct answer. 4.65e+04. What is the difference between the highest and the second highest Number of refugees of 1993?
Your response must be concise. 2.04e+05. What is the difference between the highest and the lowest Number of refugees in 1990?
Your answer should be very brief. 1.25e+05. What is the difference between the highest and the lowest Number of refugees of 1991?
Provide a succinct answer. 7.12e+04. What is the difference between the highest and the lowest Number of refugees in 1992?
Give a very brief answer. 7.10e+04. What is the difference between the highest and the lowest Number of refugees of 1993?
Make the answer very short. 2.76e+05. 